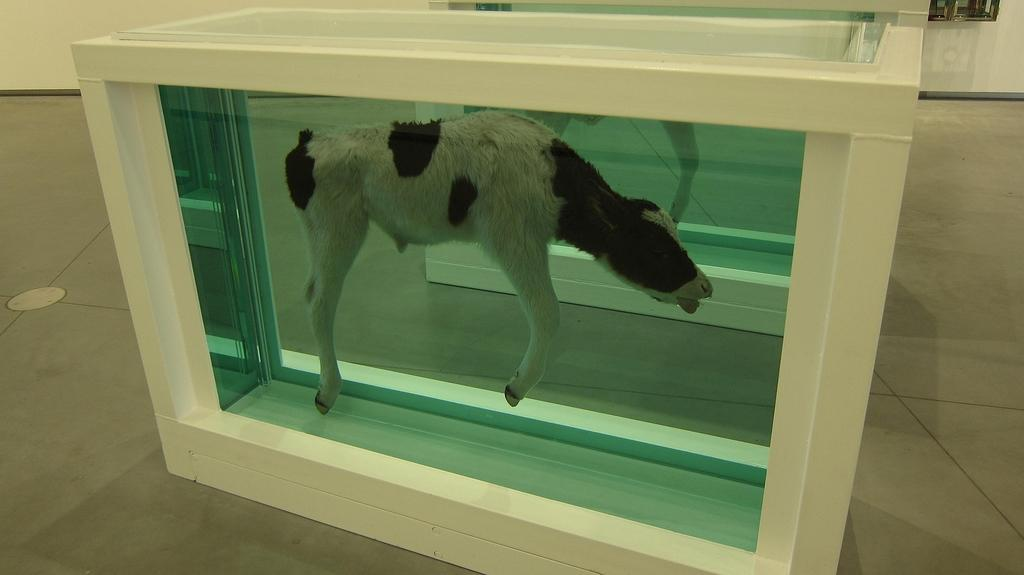What is the main subject in the foreground of the image? There is a calf in the foreground of the image. Where is the calf located? The calf is in a box. What can be seen in the background of the image? There is a wall in the background of the image. In which setting was the image taken? The image was taken in a hall. How many corks are visible in the image? There are no corks present in the image. What type of help is the calf receiving in the image? The image does not depict the calf receiving any help; it is simply in a box. What class is being taught in the image? There is no class being taught in the image; it features a calf in a box in a hall. 